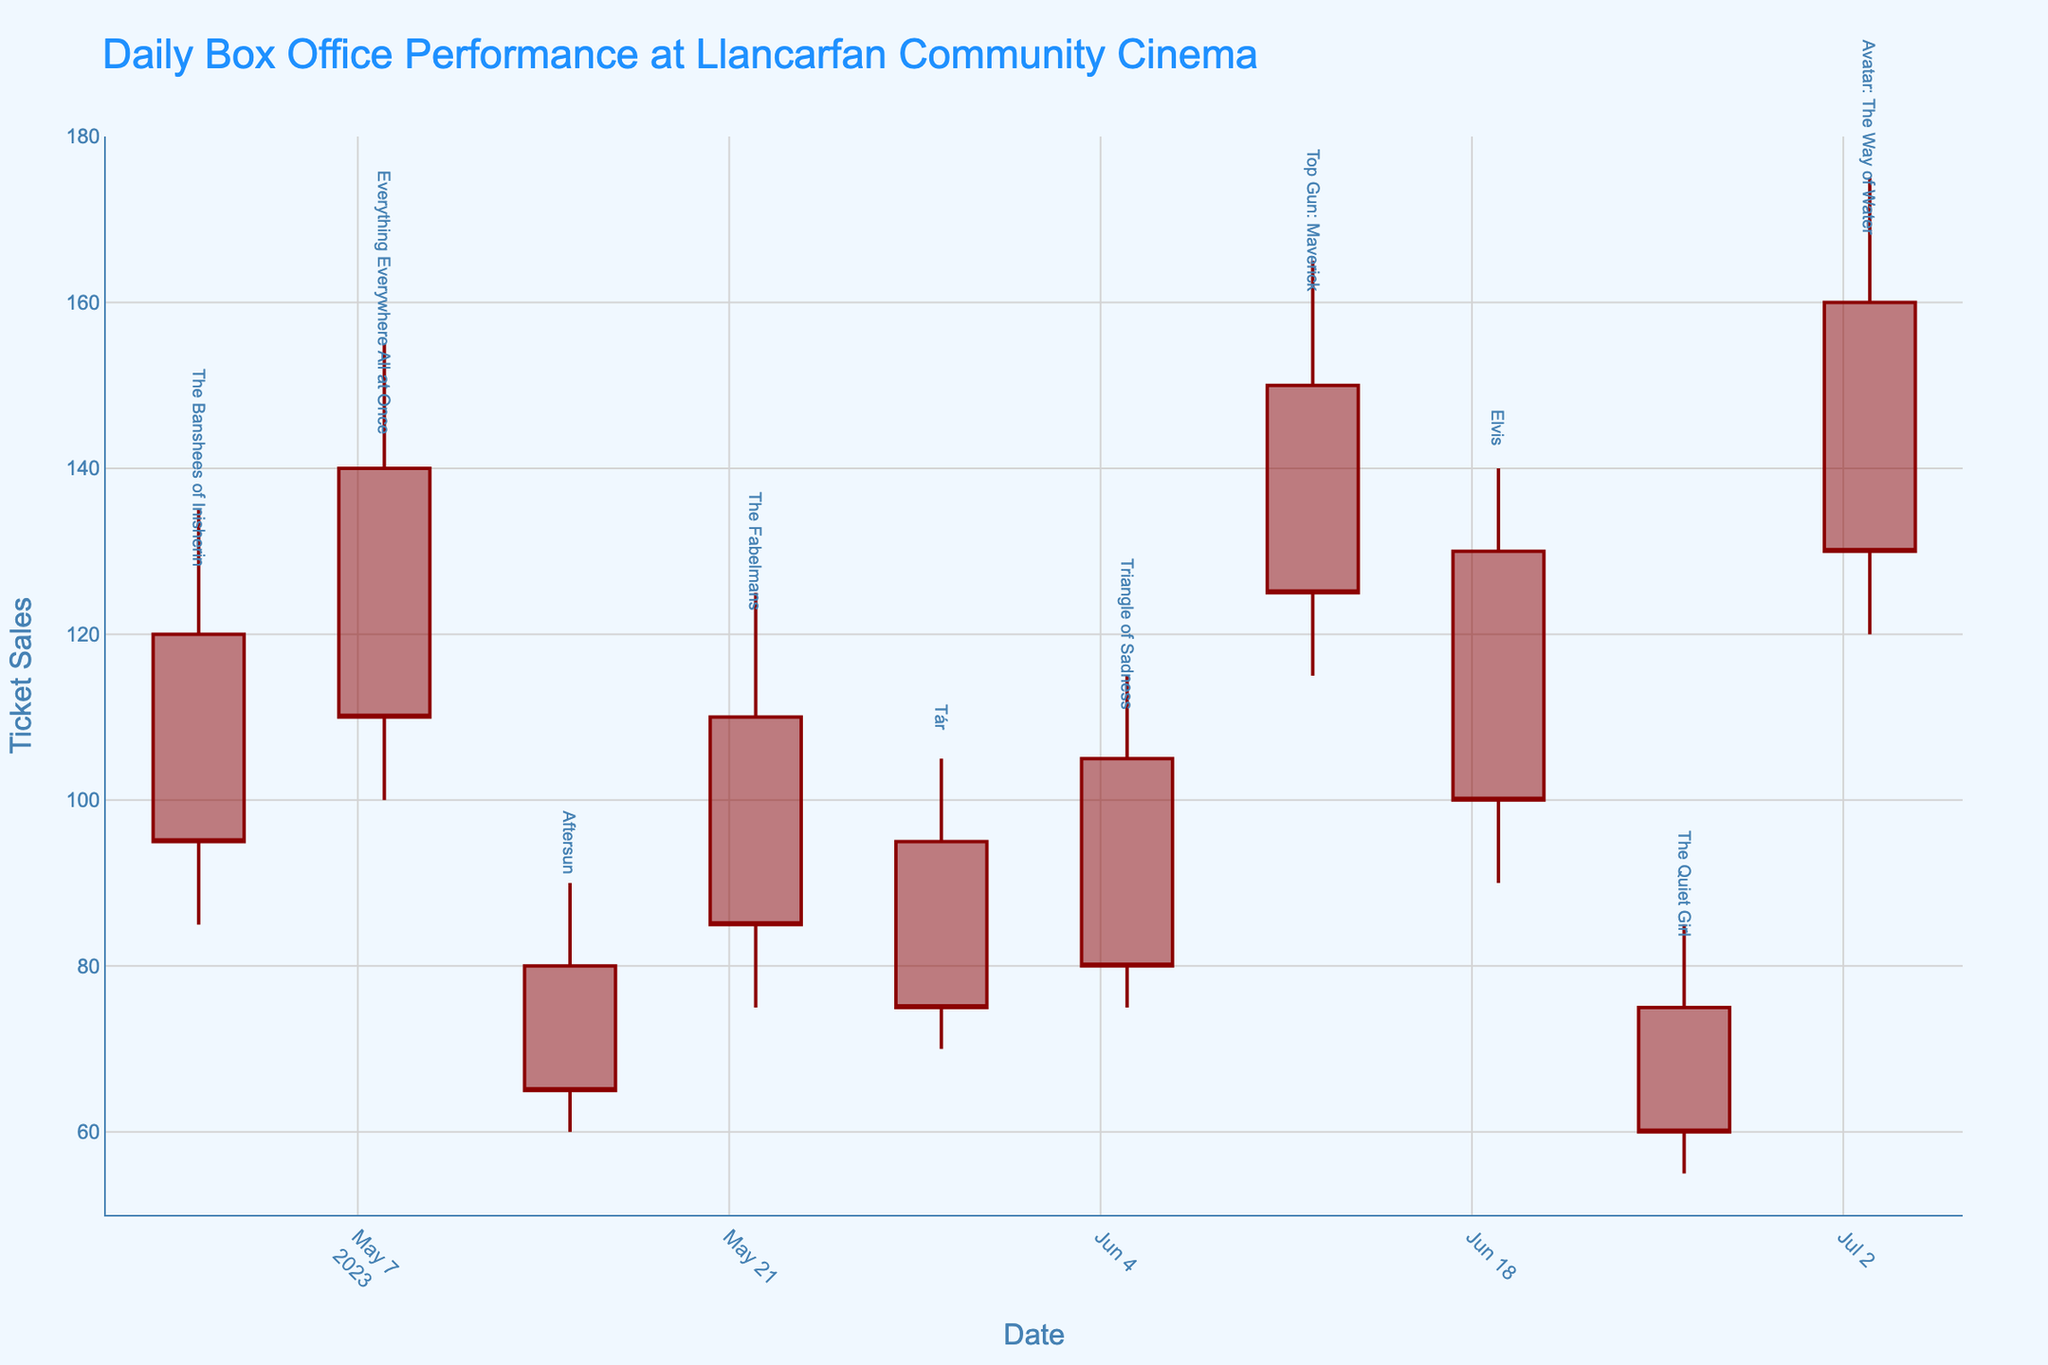what's the film with the highest closing ticket sales? The closing ticket sales for each film are shown in the figure. Compare all the closing ticket sales values and identify the highest one.
Answer: Avatar: The Way of Water which film had the lowest opening ticket sales? Look at the opening ticket sales for each film from the chart. Compare the values and find the lowest one.
Answer: The Quiet Girl which week had the highest ticket sales for any film? The highest ticket sales for any week can be found by looking at the highest value across all weeks.
Answer: Avatar: The Way of Water, week of 2023-07-03 what is the total sum of closing ticket sales for all films? Add up all the closing ticket sales values from the chart. The values are 95, 110, 65, 85, 75, 80, 125, 100, 60, 130. Summing these values: 95 + 110 + 65 + 85 + 75 + 80 + 125 + 100 + 60 + 130 = 925
Answer: 925 how many films had closing ticket sales higher than 100? Identify which closing ticket sales values are above 100. These are 110, 125, and 130. Count these values.
Answer: 3 which film showed the greatest decrease in ticket sales from opening to closing? Calculate the difference between opening and closing ticket sales for each film. The film with the largest difference indicates the greatest decrease.
Answer: Top Gun: Maverick which weeks had a high that was greater than or equal to 150 ticket sales? Review the chart for each week's high and identify the weeks where the high value is greater than or equal to 150. These values will be 150 and above.
Answer: Top Gun: Maverick (week of 2023-06-12), Everything Everywhere All at Once (week of 2023-05-08), Avatar: The Way of Water (week of 2023-07-03) what is the average of the high ticket sales across all films? Sum up all the high ticket sales values and divide by the number of films. The values are 135, 155, 90, 125, 105, 115, 165, 140, 85, 175. Add them up: 135 + 155 + 90 + 125 + 105 + 115 + 165 + 140 + 85 + 175 = 1290. Divide by the number of films (10): 1290 / 10 = 129
Answer: 129 